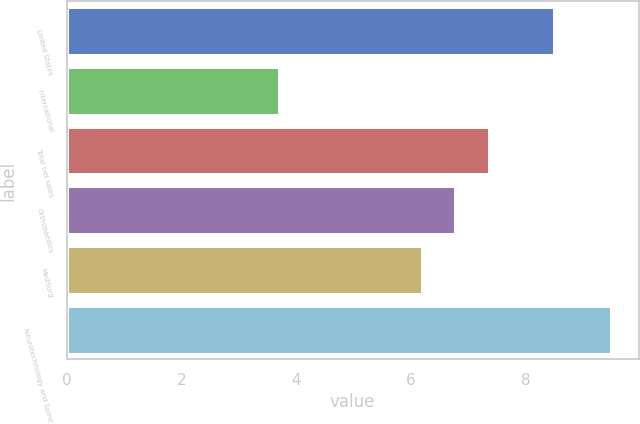Convert chart. <chart><loc_0><loc_0><loc_500><loc_500><bar_chart><fcel>United States<fcel>International<fcel>Total net sales<fcel>Orthopaedics<fcel>MedSurg<fcel>Neurotechnology and Spine<nl><fcel>8.5<fcel>3.7<fcel>7.36<fcel>6.78<fcel>6.2<fcel>9.5<nl></chart> 